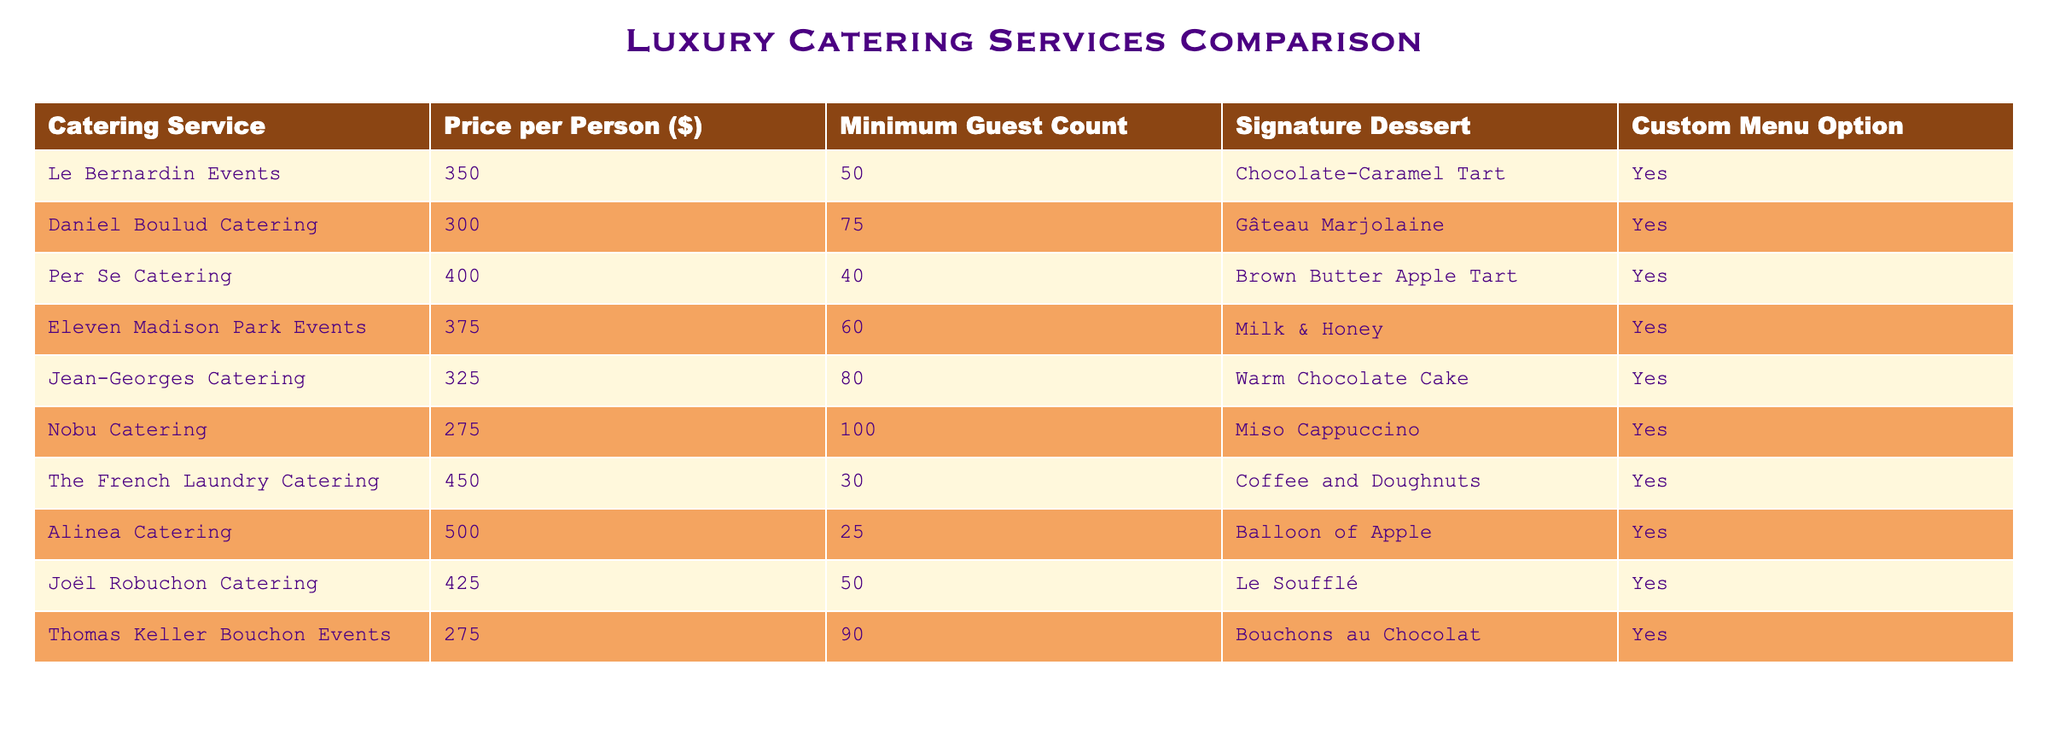What is the price per person for Le Bernardin Events? Referring to the table, Le Bernardin Events has a price of $350 per person listed in the 'Price per Person ($)' column.
Answer: 350 What is the minimum guest count required by Nobu Catering? According to the table, Nobu Catering has a minimum guest count of 100, as specified under the 'Minimum Guest Count' column.
Answer: 100 Which catering service has the most expensive price per person? Looking through the 'Price per Person ($)' column, Alinea Catering has the highest price at $500.
Answer: 500 Is there a custom menu option available with Jean-Georges Catering? The 'Custom Menu Option' column shows "Yes" for Jean-Georges Catering, meaning there is a custom menu option available.
Answer: Yes What is the average price per person for all catering services listed? To find the average price: First, sum up all the prices: (350 + 300 + 400 + 375 + 325 + 275 + 450 + 500 + 425 + 275) = 3875. Since there are 10 services, divide by 10: 3875 / 10 = 387.5.
Answer: 387.5 How many catering services have a minimum guest count of more than 70? From the 'Minimum Guest Count' column, we look for values exceeding 70: Daniel Boulud Catering (75), Jean-Georges Catering (80), and Nobu Catering (100). That gives us 3 services with a minimum guest count greater than 70.
Answer: 3 Which catering service offers the signature dessert “Milk & Honey”? By scanning the 'Signature Dessert' column, Eleven Madison Park Events is associated with the dessert “Milk & Honey”.
Answer: Eleven Madison Park Events What is the price difference between the lowest and highest priced catering services? Alinea Catering has the highest price at $500 and Nobu Catering has the lowest at $275. The difference is calculated as 500 - 275 = 225.
Answer: 225 Does Per Se Catering provide a custom menu option? The table indicates "Yes" in the 'Custom Menu Option' column for Per Se Catering, confirming the availability of a custom menu option.
Answer: Yes Which catering service requires the smallest minimum guest count? Looking at the 'Minimum Guest Count' column, The French Laundry Catering has the smallest count of 30 guests required.
Answer: The French Laundry Catering 